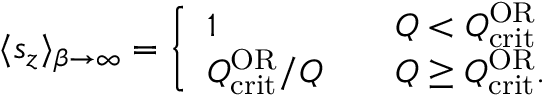<formula> <loc_0><loc_0><loc_500><loc_500>\langle s _ { z } \rangle _ { \beta \to \infty } = \left \{ \begin{array} { l l } { 1 } & { \quad Q < Q _ { c r i t } ^ { O R } } \\ { Q _ { c r i t } ^ { O R } / Q } & { \quad Q \geq Q _ { c r i t } ^ { O R } . } \end{array}</formula> 